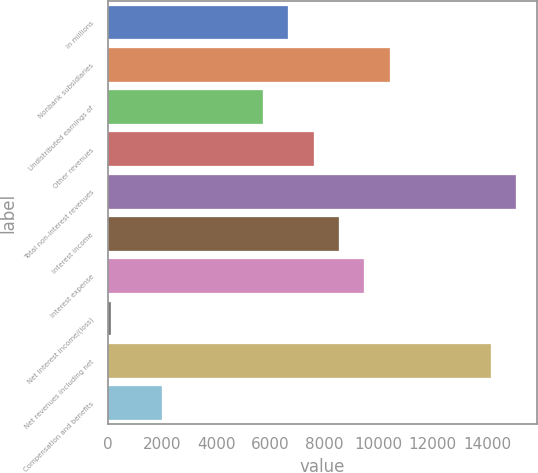Convert chart. <chart><loc_0><loc_0><loc_500><loc_500><bar_chart><fcel>in millions<fcel>Nonbank subsidiaries<fcel>Undistributed earnings of<fcel>Other revenues<fcel>Total non-interest revenues<fcel>Interest income<fcel>Interest expense<fcel>Net interest income/(loss)<fcel>Net revenues including net<fcel>Compensation and benefits<nl><fcel>6663.6<fcel>10406.8<fcel>5727.8<fcel>7599.4<fcel>15085.8<fcel>8535.2<fcel>9471<fcel>113<fcel>14150<fcel>1984.6<nl></chart> 